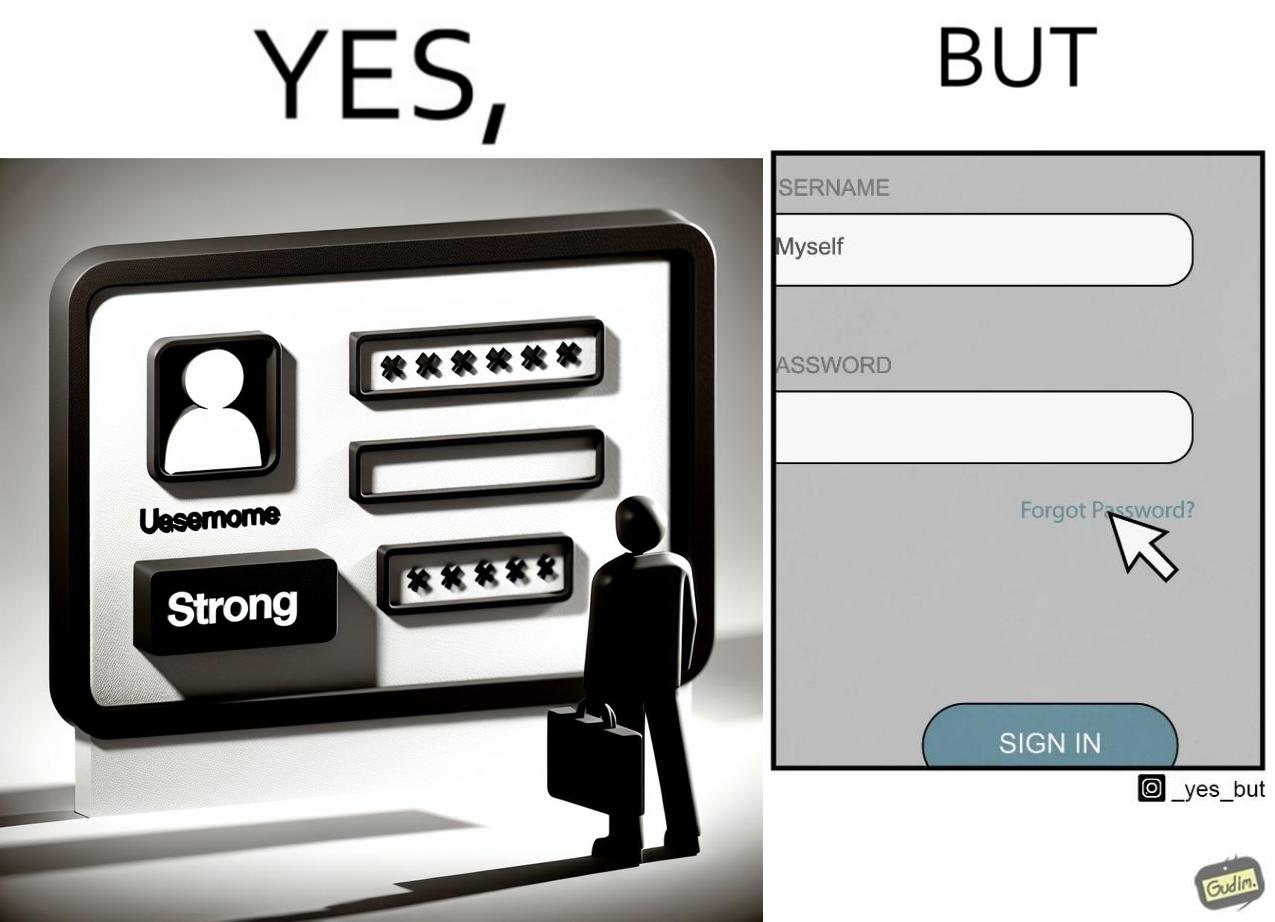Is this image satirical or non-satirical? Yes, this image is satirical. 